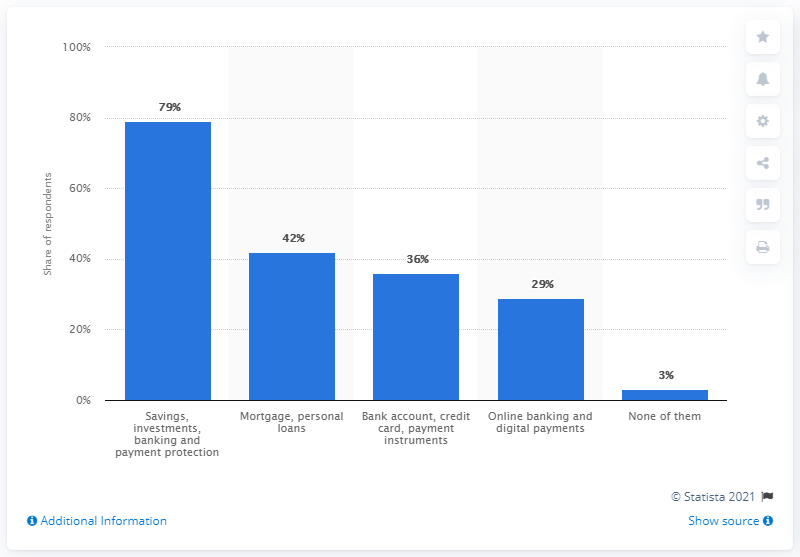Point out several critical features in this image. According to a survey of Italians, 79% expressed interest in learning more about saving, investments, banking, and payment protection. 